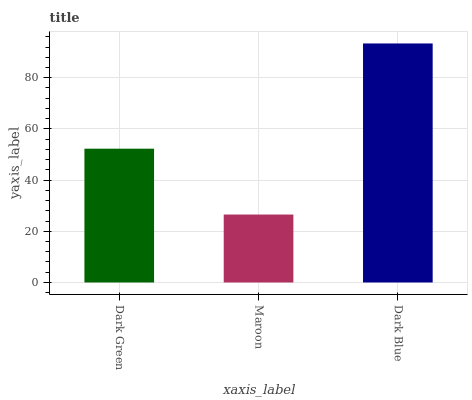Is Maroon the minimum?
Answer yes or no. Yes. Is Dark Blue the maximum?
Answer yes or no. Yes. Is Dark Blue the minimum?
Answer yes or no. No. Is Maroon the maximum?
Answer yes or no. No. Is Dark Blue greater than Maroon?
Answer yes or no. Yes. Is Maroon less than Dark Blue?
Answer yes or no. Yes. Is Maroon greater than Dark Blue?
Answer yes or no. No. Is Dark Blue less than Maroon?
Answer yes or no. No. Is Dark Green the high median?
Answer yes or no. Yes. Is Dark Green the low median?
Answer yes or no. Yes. Is Dark Blue the high median?
Answer yes or no. No. Is Maroon the low median?
Answer yes or no. No. 